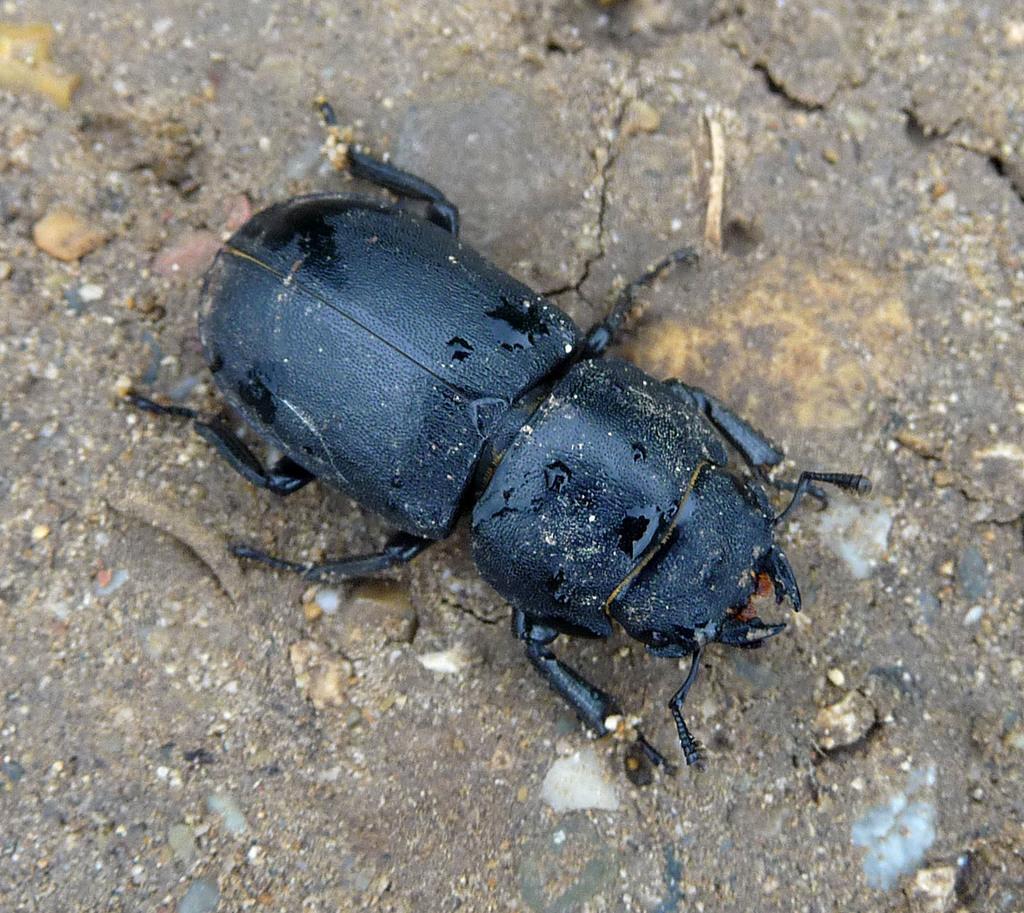How would you summarize this image in a sentence or two? In this image there is an insect on the land. Insect is in black color. 